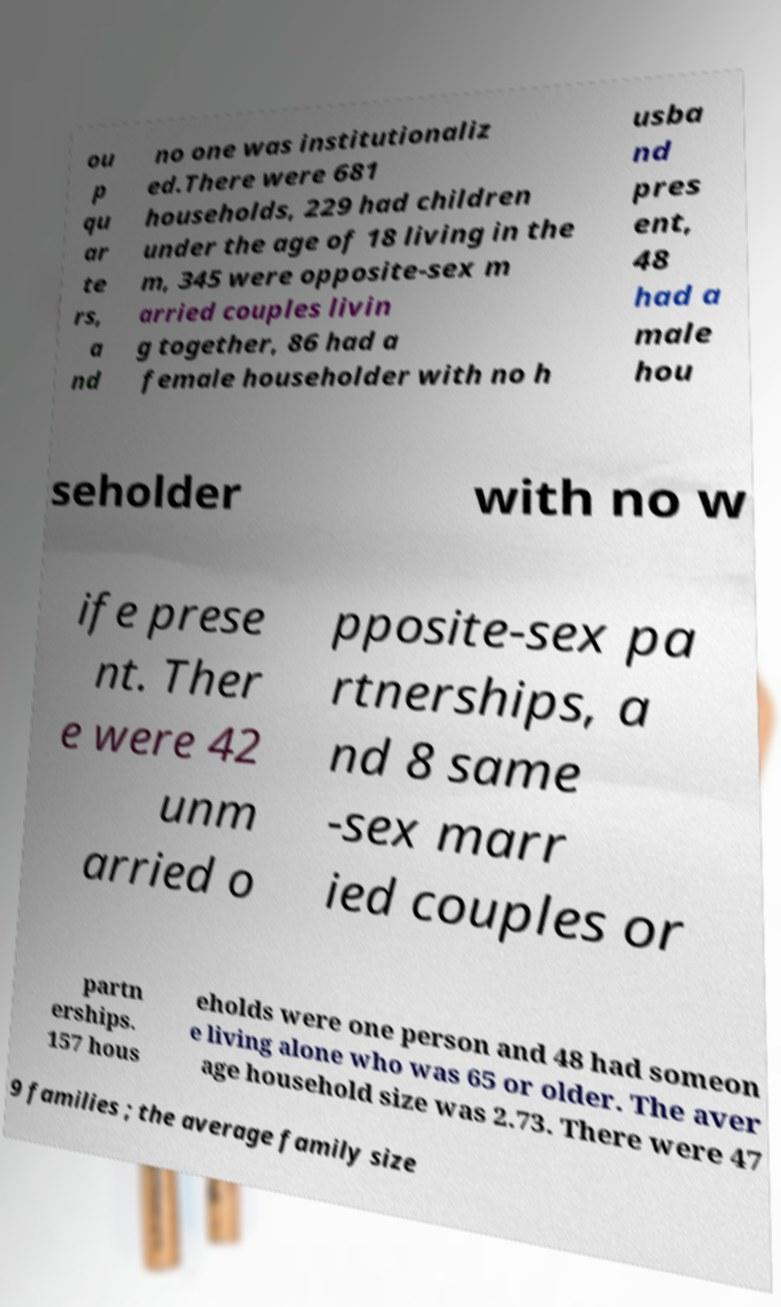Can you read and provide the text displayed in the image?This photo seems to have some interesting text. Can you extract and type it out for me? ou p qu ar te rs, a nd no one was institutionaliz ed.There were 681 households, 229 had children under the age of 18 living in the m, 345 were opposite-sex m arried couples livin g together, 86 had a female householder with no h usba nd pres ent, 48 had a male hou seholder with no w ife prese nt. Ther e were 42 unm arried o pposite-sex pa rtnerships, a nd 8 same -sex marr ied couples or partn erships. 157 hous eholds were one person and 48 had someon e living alone who was 65 or older. The aver age household size was 2.73. There were 47 9 families ; the average family size 